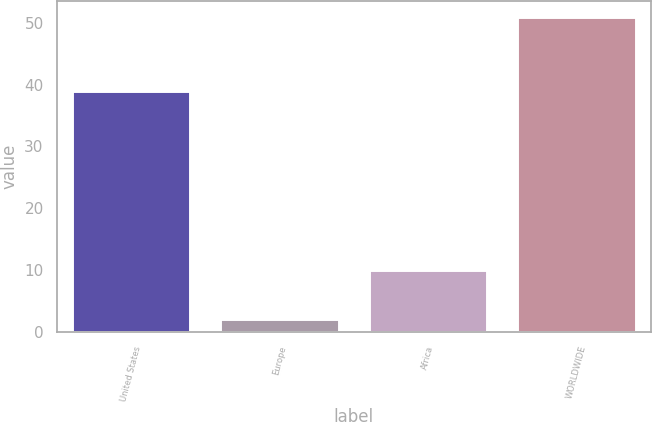<chart> <loc_0><loc_0><loc_500><loc_500><bar_chart><fcel>United States<fcel>Europe<fcel>Africa<fcel>WORLDWIDE<nl><fcel>39<fcel>2<fcel>10<fcel>51<nl></chart> 